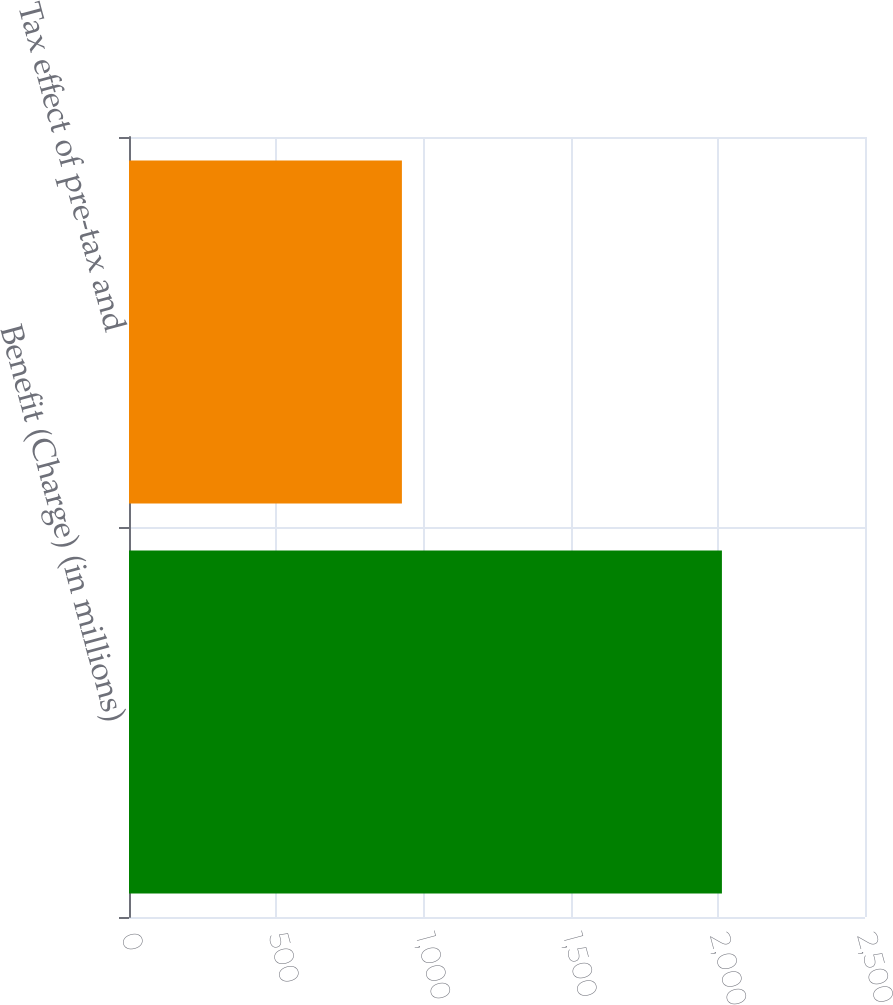<chart> <loc_0><loc_0><loc_500><loc_500><bar_chart><fcel>Benefit (Charge) (in millions)<fcel>Tax effect of pre-tax and<nl><fcel>2014<fcel>927<nl></chart> 